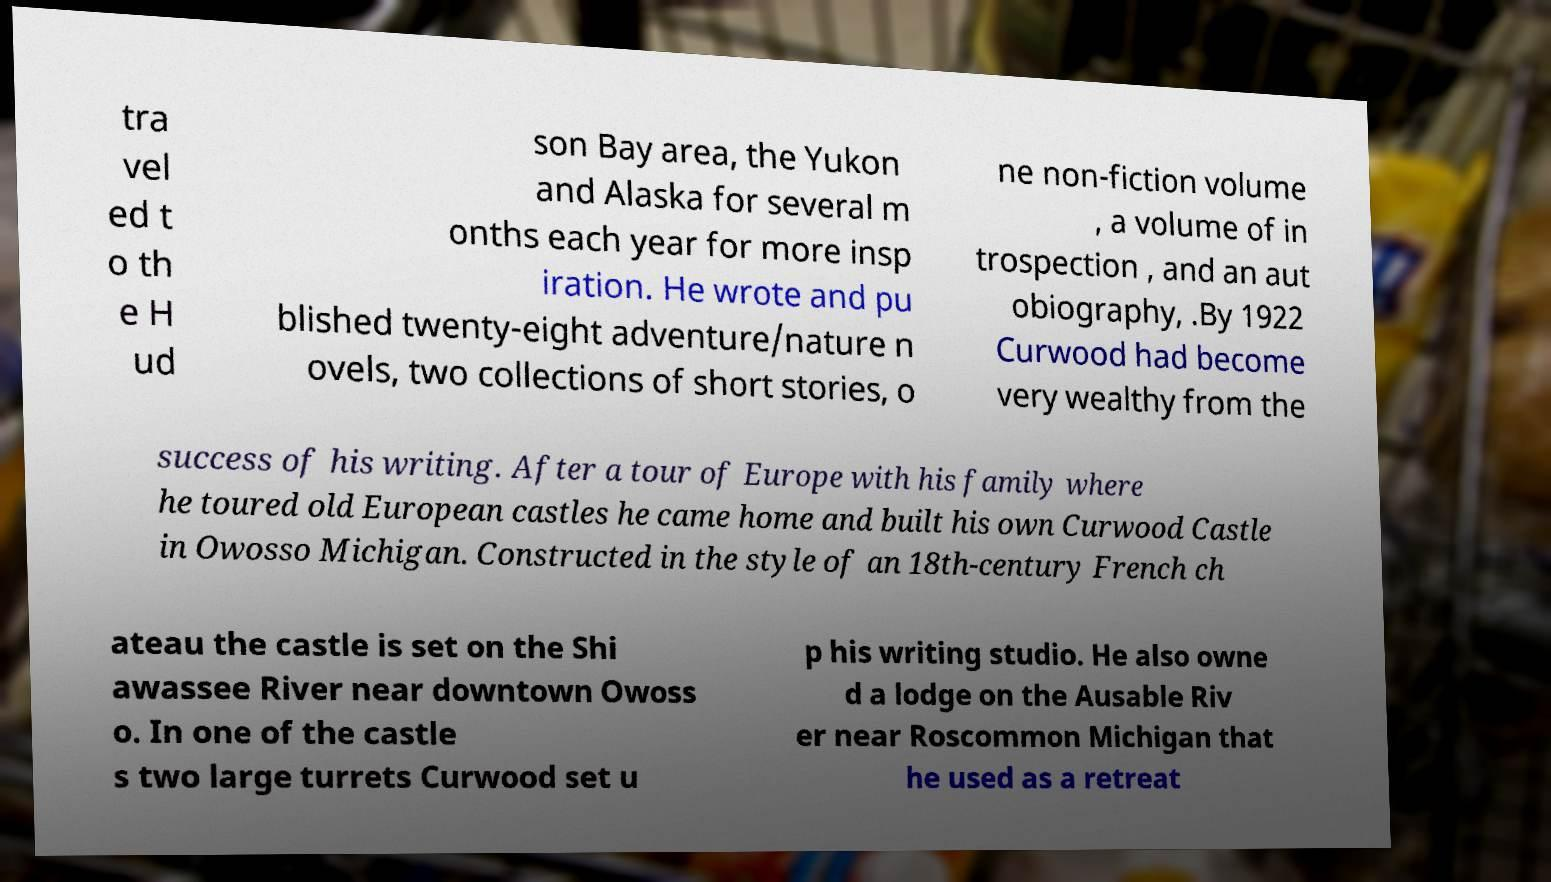Could you extract and type out the text from this image? tra vel ed t o th e H ud son Bay area, the Yukon and Alaska for several m onths each year for more insp iration. He wrote and pu blished twenty-eight adventure/nature n ovels, two collections of short stories, o ne non-fiction volume , a volume of in trospection , and an aut obiography, .By 1922 Curwood had become very wealthy from the success of his writing. After a tour of Europe with his family where he toured old European castles he came home and built his own Curwood Castle in Owosso Michigan. Constructed in the style of an 18th-century French ch ateau the castle is set on the Shi awassee River near downtown Owoss o. In one of the castle s two large turrets Curwood set u p his writing studio. He also owne d a lodge on the Ausable Riv er near Roscommon Michigan that he used as a retreat 